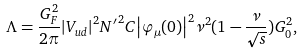Convert formula to latex. <formula><loc_0><loc_0><loc_500><loc_500>\Lambda = \frac { G ^ { 2 } _ { F } } { 2 \pi } { \left | V _ { u d } \right | } ^ { 2 } { { N } ^ { \prime } } ^ { 2 } C { \left | \varphi _ { \mu } ( 0 ) \right | } ^ { 2 } { \nu } ^ { 2 } ( 1 - \frac { \nu } { \sqrt { s } } ) { G _ { 0 } ^ { 2 } } ,</formula> 